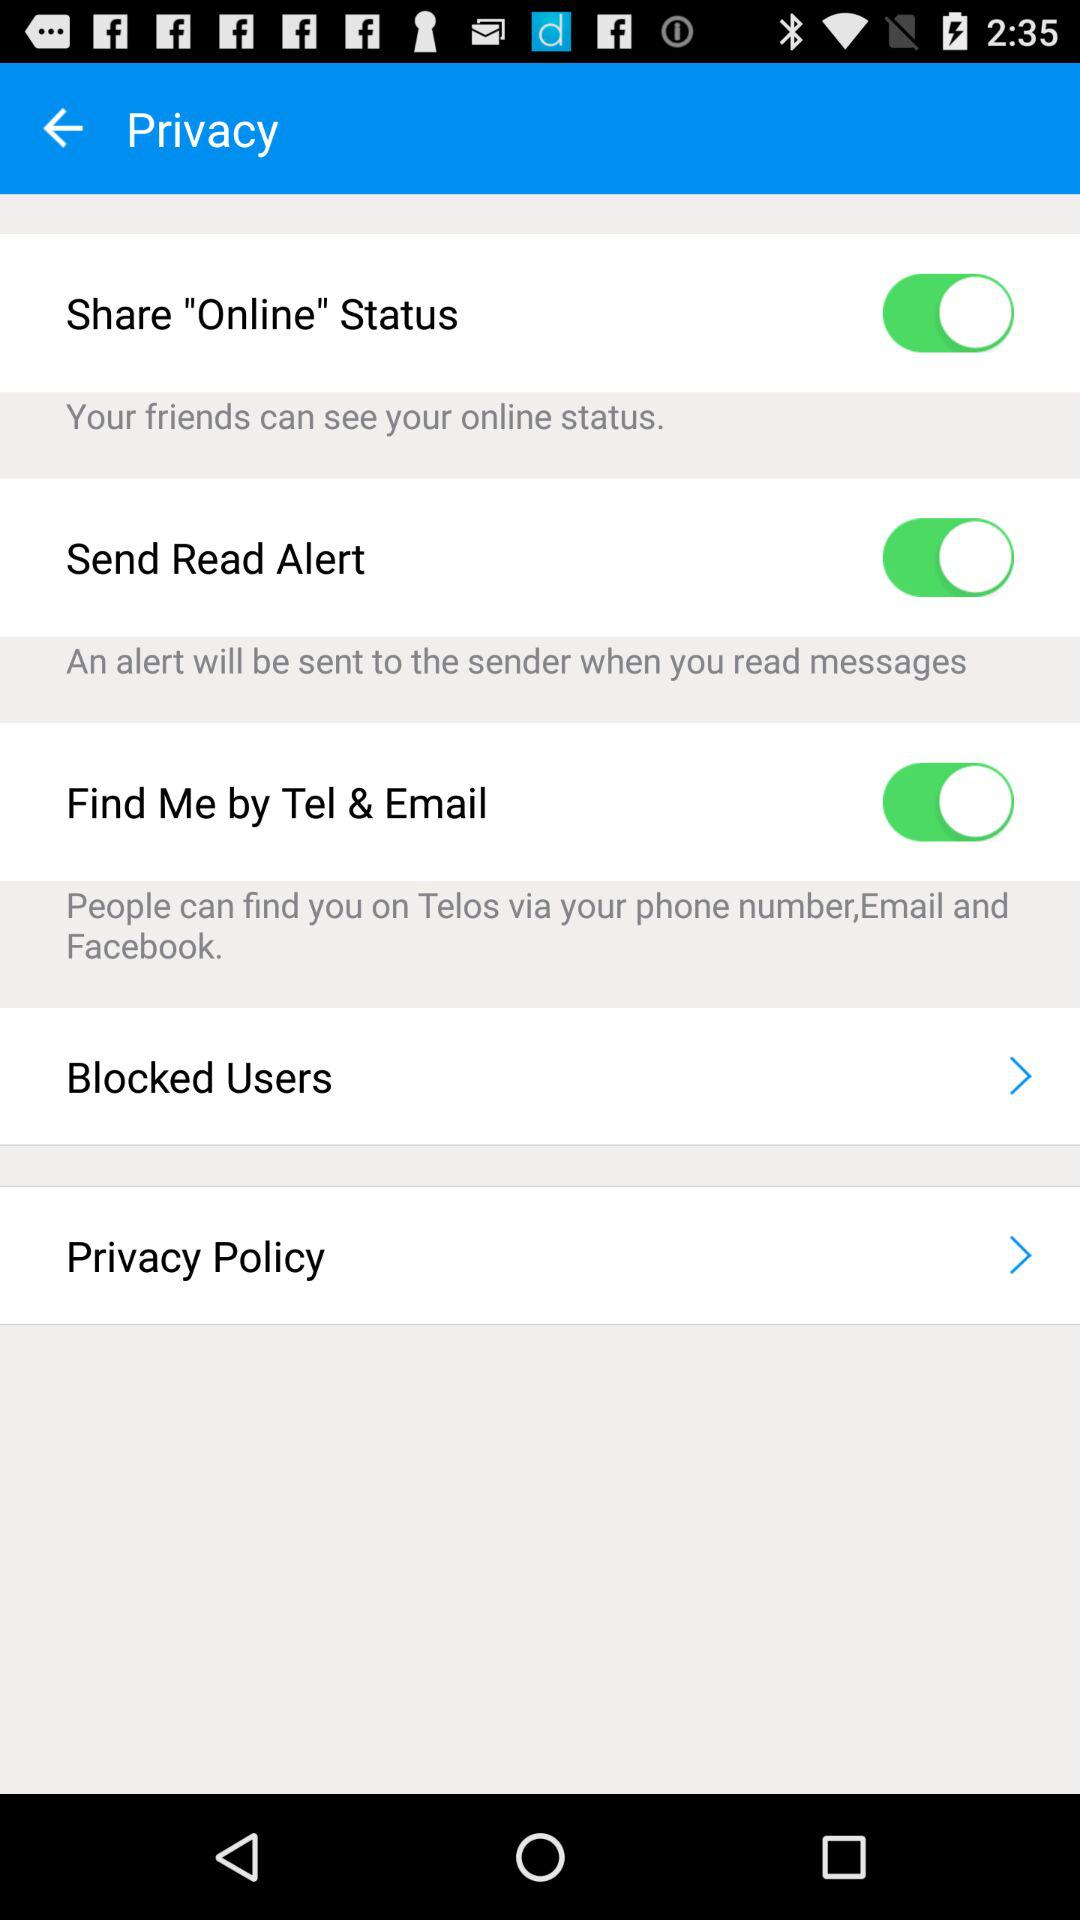What is the current status of "Send Read Alert"? The status is "on". 